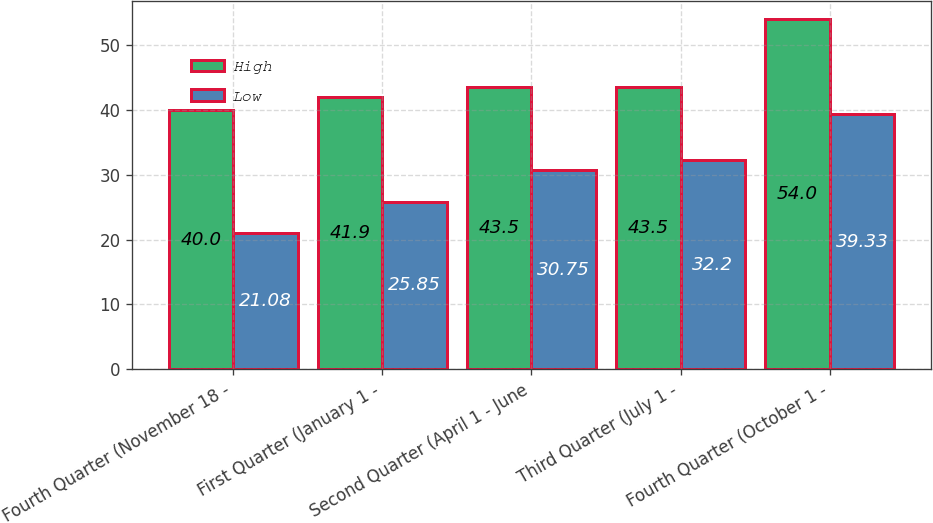Convert chart to OTSL. <chart><loc_0><loc_0><loc_500><loc_500><stacked_bar_chart><ecel><fcel>Fourth Quarter (November 18 -<fcel>First Quarter (January 1 -<fcel>Second Quarter (April 1 - June<fcel>Third Quarter (July 1 -<fcel>Fourth Quarter (October 1 -<nl><fcel>High<fcel>40<fcel>41.9<fcel>43.5<fcel>43.5<fcel>54<nl><fcel>Low<fcel>21.08<fcel>25.85<fcel>30.75<fcel>32.2<fcel>39.33<nl></chart> 